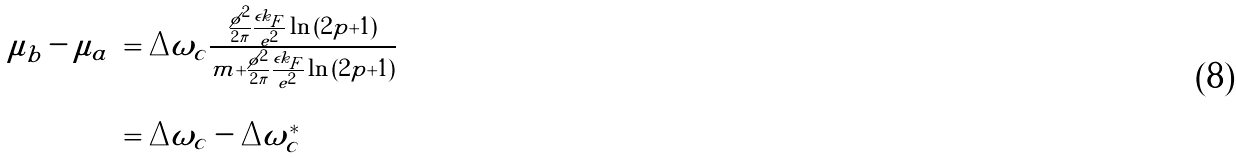<formula> <loc_0><loc_0><loc_500><loc_500>\begin{array} { l l } \mu _ { b } - \mu _ { a } & = \Delta \omega _ { c } \frac { \frac { \tilde { \phi } ^ { 2 } } { 2 \pi } \frac { \epsilon k _ { F } } { e ^ { 2 } } \ln { ( 2 p + 1 ) } } { m + \frac { \tilde { \phi } ^ { 2 } } { 2 \pi } \frac { \epsilon k _ { F } } { e ^ { 2 } } \ln { ( 2 p + 1 ) } } \\ \\ & = \Delta \omega _ { c } - \Delta \omega _ { c } ^ { * } \end{array}</formula> 